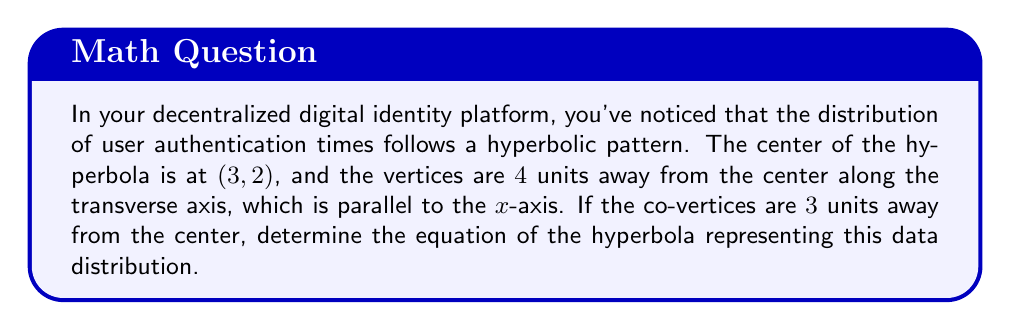Can you solve this math problem? Let's approach this step-by-step:

1) The general equation of a hyperbola with center (h, k) and transverse axis parallel to the x-axis is:

   $$\frac{(x-h)^2}{a^2} - \frac{(y-k)^2}{b^2} = 1$$

2) We're given that the center is at (3, 2), so h = 3 and k = 2.

3) The vertices are 4 units away from the center, so a = 4.

4) The co-vertices are 3 units away from the center, so b = 3.

5) Substituting these values into the general equation:

   $$\frac{(x-3)^2}{4^2} - \frac{(y-2)^2}{3^2} = 1$$

6) Simplify:

   $$\frac{(x-3)^2}{16} - \frac{(y-2)^2}{9} = 1$$

This is the equation of the hyperbola representing the data distribution in your digital identity network.
Answer: $$\frac{(x-3)^2}{16} - \frac{(y-2)^2}{9} = 1$$ 